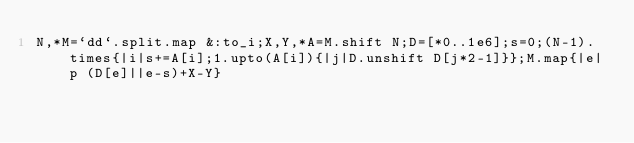Convert code to text. <code><loc_0><loc_0><loc_500><loc_500><_Ruby_>N,*M=`dd`.split.map &:to_i;X,Y,*A=M.shift N;D=[*0..1e6];s=0;(N-1).times{|i|s+=A[i];1.upto(A[i]){|j|D.unshift D[j*2-1]}};M.map{|e|p (D[e]||e-s)+X-Y}</code> 